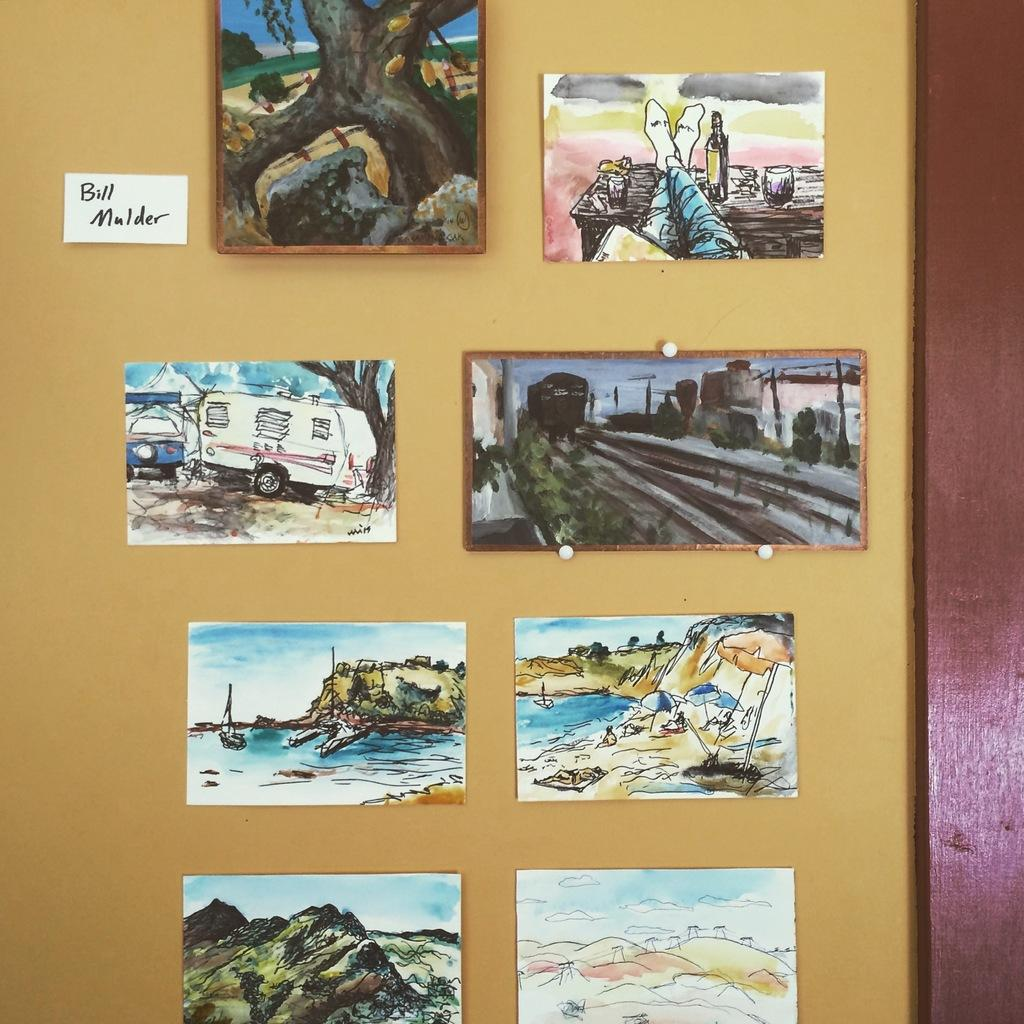What can be seen on the wall in the foreground area of the image? There are posters and frames on the wall in the foreground area of the image. Can you describe the small paper with text on the left side of the image? Yes, there is a small paper with text on the left side of the image. How many dogs are present in the image? There are no dogs present in the image. What type of guide is available for visitors in the image? There is no guide available for visitors in the image. 